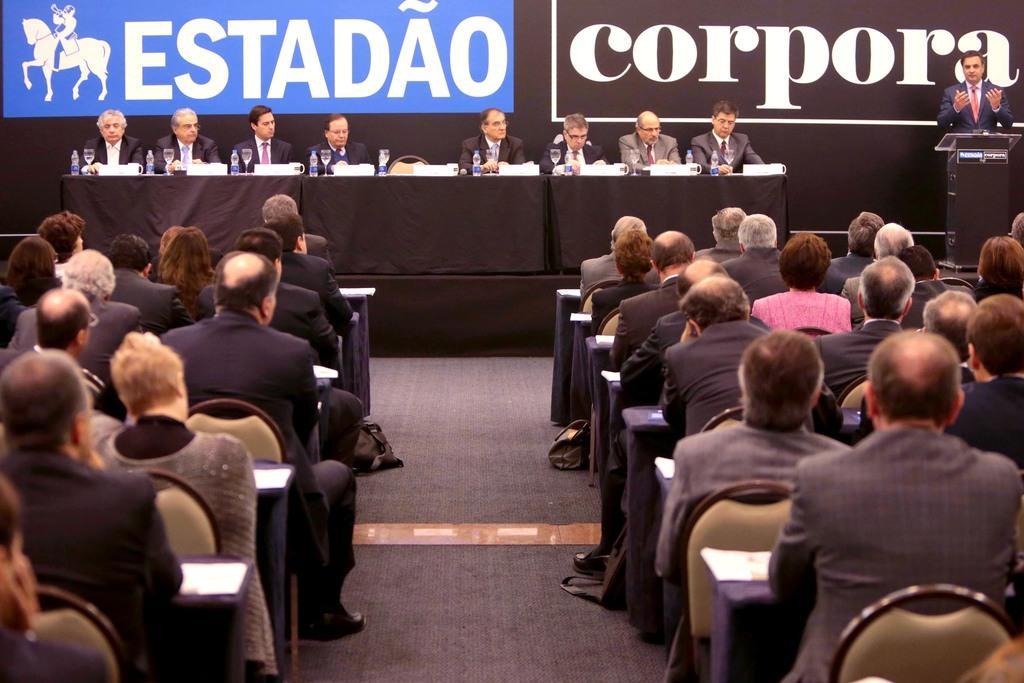Can you describe this image briefly? This image consists of many persons. At the bottom, there is a floor. In the front, there are few persons sitting in the chairs. In front of the tables on which we can see water bottles and glasses. On the right, there is a man speaking in a mic in front of the podium. In the background, there are banners. 